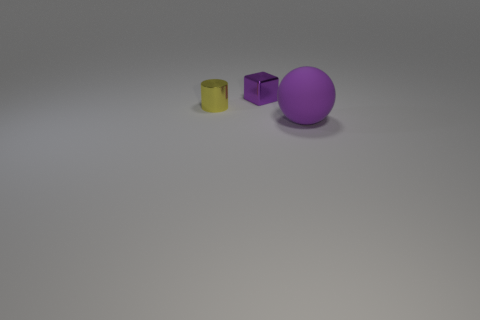There is a object that is both to the right of the cylinder and in front of the small purple metallic cube; what size is it?
Your answer should be compact. Large. There is a ball; is its color the same as the small object to the left of the purple cube?
Ensure brevity in your answer.  No. What number of objects are either yellow metallic cylinders or tiny metal objects to the right of the tiny cylinder?
Make the answer very short. 2. How many other objects are the same material as the big purple sphere?
Your answer should be very brief. 0. How many objects are either large blue spheres or tiny metal blocks?
Offer a terse response. 1. Are there more things behind the cylinder than purple cubes that are behind the small purple cube?
Your answer should be very brief. Yes. Does the thing that is in front of the yellow metallic thing have the same color as the small object that is behind the yellow cylinder?
Your answer should be compact. Yes. There is a metallic object right of the small thing on the left side of the purple object that is behind the purple rubber thing; how big is it?
Keep it short and to the point. Small. Is the number of metallic cylinders that are left of the tiny block greater than the number of large green matte objects?
Provide a short and direct response. Yes. There is a large purple matte object; is it the same shape as the small object on the left side of the small block?
Your answer should be very brief. No. 